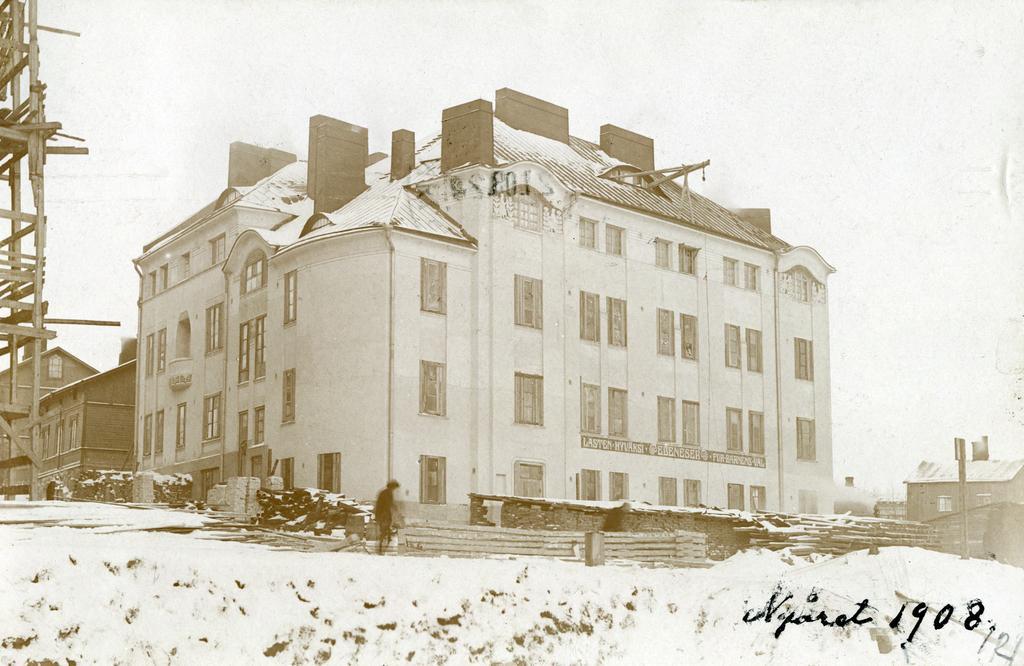Can you describe this image briefly? In this picture we can see a person on the ground, fence, buildings with windows and in the background we can see the sky. 